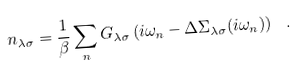<formula> <loc_0><loc_0><loc_500><loc_500>n _ { \lambda \sigma } = \frac { 1 } { \beta } \sum _ { n } G _ { \lambda \sigma } \left ( i \omega _ { n } - \Delta \Sigma _ { \lambda \sigma } ( i \omega _ { n } ) \right ) \ .</formula> 